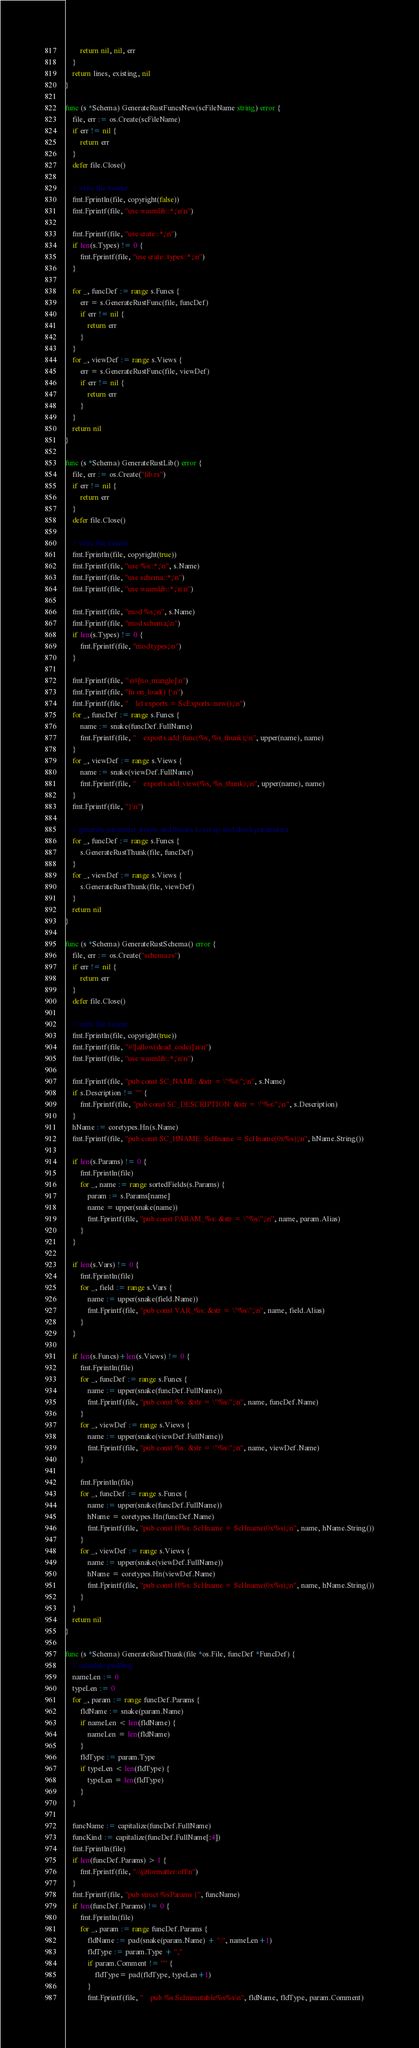<code> <loc_0><loc_0><loc_500><loc_500><_Go_>		return nil, nil, err
	}
	return lines, existing, nil
}

func (s *Schema) GenerateRustFuncsNew(scFileName string) error {
	file, err := os.Create(scFileName)
	if err != nil {
		return err
	}
	defer file.Close()

	// write file header
	fmt.Fprintln(file, copyright(false))
	fmt.Fprintf(file, "use wasmlib::*;\n\n")

	fmt.Fprintf(file, "use crate::*;\n")
	if len(s.Types) != 0 {
		fmt.Fprintf(file, "use crate::types::*;\n")
	}

	for _, funcDef := range s.Funcs {
		err = s.GenerateRustFunc(file, funcDef)
		if err != nil {
			return err
		}
	}
	for _, viewDef := range s.Views {
		err = s.GenerateRustFunc(file, viewDef)
		if err != nil {
			return err
		}
	}
	return nil
}

func (s *Schema) GenerateRustLib() error {
	file, err := os.Create("lib.rs")
	if err != nil {
		return err
	}
	defer file.Close()

	// write file header
	fmt.Fprintln(file, copyright(true))
	fmt.Fprintf(file, "use %s::*;\n", s.Name)
	fmt.Fprintf(file, "use schema::*;\n")
	fmt.Fprintf(file, "use wasmlib::*;\n\n")

	fmt.Fprintf(file, "mod %s;\n", s.Name)
	fmt.Fprintf(file, "mod schema;\n")
	if len(s.Types) != 0 {
		fmt.Fprintf(file, "mod types;\n")
	}

	fmt.Fprintf(file, "\n#[no_mangle]\n")
	fmt.Fprintf(file, "fn on_load() {\n")
	fmt.Fprintf(file, "    let exports = ScExports::new();\n")
	for _, funcDef := range s.Funcs {
		name := snake(funcDef.FullName)
		fmt.Fprintf(file, "    exports.add_func(%s, %s_thunk);\n", upper(name), name)
	}
	for _, viewDef := range s.Views {
		name := snake(viewDef.FullName)
		fmt.Fprintf(file, "    exports.add_view(%s, %s_thunk);\n", upper(name), name)
	}
	fmt.Fprintf(file, "}\n")

	// generate parameter structs and thunks to set up and check parameters
	for _, funcDef := range s.Funcs {
		s.GenerateRustThunk(file, funcDef)
	}
	for _, viewDef := range s.Views {
		s.GenerateRustThunk(file, viewDef)
	}
	return nil
}

func (s *Schema) GenerateRustSchema() error {
	file, err := os.Create("schema.rs")
	if err != nil {
		return err
	}
	defer file.Close()

	// write file header
	fmt.Fprintln(file, copyright(true))
	fmt.Fprintf(file, "#![allow(dead_code)]\n\n")
	fmt.Fprintf(file, "use wasmlib::*;\n\n")

	fmt.Fprintf(file, "pub const SC_NAME: &str = \"%s\";\n", s.Name)
	if s.Description != "" {
		fmt.Fprintf(file, "pub const SC_DESCRIPTION: &str = \"%s\";\n", s.Description)
	}
	hName := coretypes.Hn(s.Name)
	fmt.Fprintf(file, "pub const SC_HNAME: ScHname = ScHname(0x%s);\n", hName.String())

	if len(s.Params) != 0 {
		fmt.Fprintln(file)
		for _, name := range sortedFields(s.Params) {
			param := s.Params[name]
			name = upper(snake(name))
			fmt.Fprintf(file, "pub const PARAM_%s: &str = \"%s\";\n", name, param.Alias)
		}
	}

	if len(s.Vars) != 0 {
		fmt.Fprintln(file)
		for _, field := range s.Vars {
			name := upper(snake(field.Name))
			fmt.Fprintf(file, "pub const VAR_%s: &str = \"%s\";\n", name, field.Alias)
		}
	}

	if len(s.Funcs)+len(s.Views) != 0 {
		fmt.Fprintln(file)
		for _, funcDef := range s.Funcs {
			name := upper(snake(funcDef.FullName))
			fmt.Fprintf(file, "pub const %s: &str = \"%s\";\n", name, funcDef.Name)
		}
		for _, viewDef := range s.Views {
			name := upper(snake(viewDef.FullName))
			fmt.Fprintf(file, "pub const %s: &str = \"%s\";\n", name, viewDef.Name)
		}

		fmt.Fprintln(file)
		for _, funcDef := range s.Funcs {
			name := upper(snake(funcDef.FullName))
			hName = coretypes.Hn(funcDef.Name)
			fmt.Fprintf(file, "pub const H%s: ScHname = ScHname(0x%s);\n", name, hName.String())
		}
		for _, viewDef := range s.Views {
			name := upper(snake(viewDef.FullName))
			hName = coretypes.Hn(viewDef.Name)
			fmt.Fprintf(file, "pub const H%s: ScHname = ScHname(0x%s);\n", name, hName.String())
		}
	}
	return nil
}

func (s *Schema) GenerateRustThunk(file *os.File, funcDef *FuncDef) {
	// calculate padding
	nameLen := 0
	typeLen := 0
	for _, param := range funcDef.Params {
		fldName := snake(param.Name)
		if nameLen < len(fldName) {
			nameLen = len(fldName)
		}
		fldType := param.Type
		if typeLen < len(fldType) {
			typeLen = len(fldType)
		}
	}

	funcName := capitalize(funcDef.FullName)
	funcKind := capitalize(funcDef.FullName[:4])
	fmt.Fprintln(file)
	if len(funcDef.Params) > 1 {
		fmt.Fprintf(file, "//@formatter:off\n")
	}
	fmt.Fprintf(file, "pub struct %sParams {", funcName)
	if len(funcDef.Params) != 0 {
		fmt.Fprintln(file)
		for _, param := range funcDef.Params {
			fldName := pad(snake(param.Name) + ":", nameLen+1)
			fldType := param.Type + ","
			if param.Comment != "" {
				fldType= pad(fldType, typeLen+1)
			}
			fmt.Fprintf(file, "    pub %s ScImmutable%s%s\n", fldName, fldType, param.Comment)</code> 